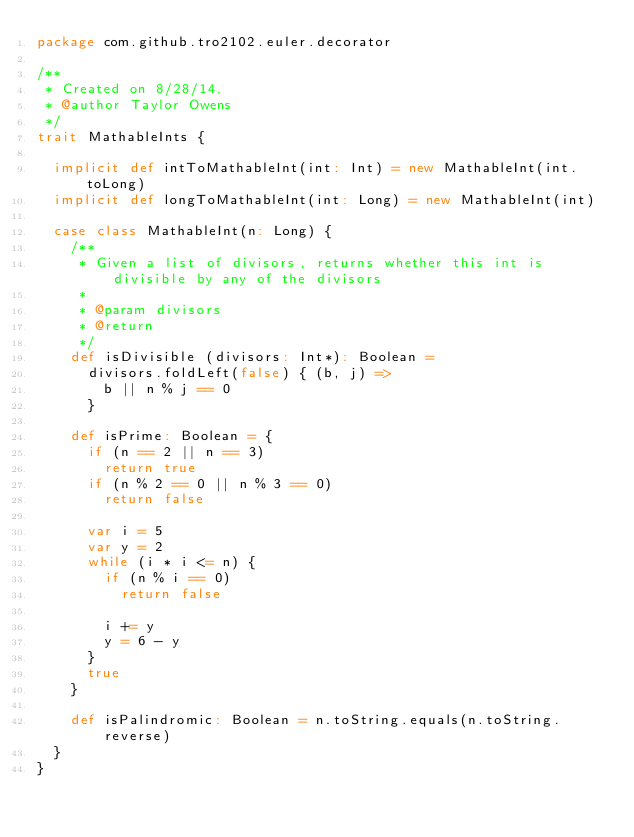Convert code to text. <code><loc_0><loc_0><loc_500><loc_500><_Scala_>package com.github.tro2102.euler.decorator

/**
 * Created on 8/28/14.
 * @author Taylor Owens
 */
trait MathableInts {

  implicit def intToMathableInt(int: Int) = new MathableInt(int.toLong)
  implicit def longToMathableInt(int: Long) = new MathableInt(int)

  case class MathableInt(n: Long) {
    /**
     * Given a list of divisors, returns whether this int is divisible by any of the divisors
     *
     * @param divisors
     * @return
     */
    def isDivisible (divisors: Int*): Boolean =
      divisors.foldLeft(false) { (b, j) =>
        b || n % j == 0
      }

    def isPrime: Boolean = {
      if (n == 2 || n == 3)
        return true
      if (n % 2 == 0 || n % 3 == 0)
        return false
      
      var i = 5
      var y = 2
      while (i * i <= n) {
        if (n % i == 0)
          return false

        i += y
        y = 6 - y
      }
      true
    }

    def isPalindromic: Boolean = n.toString.equals(n.toString.reverse)
  }
}
</code> 